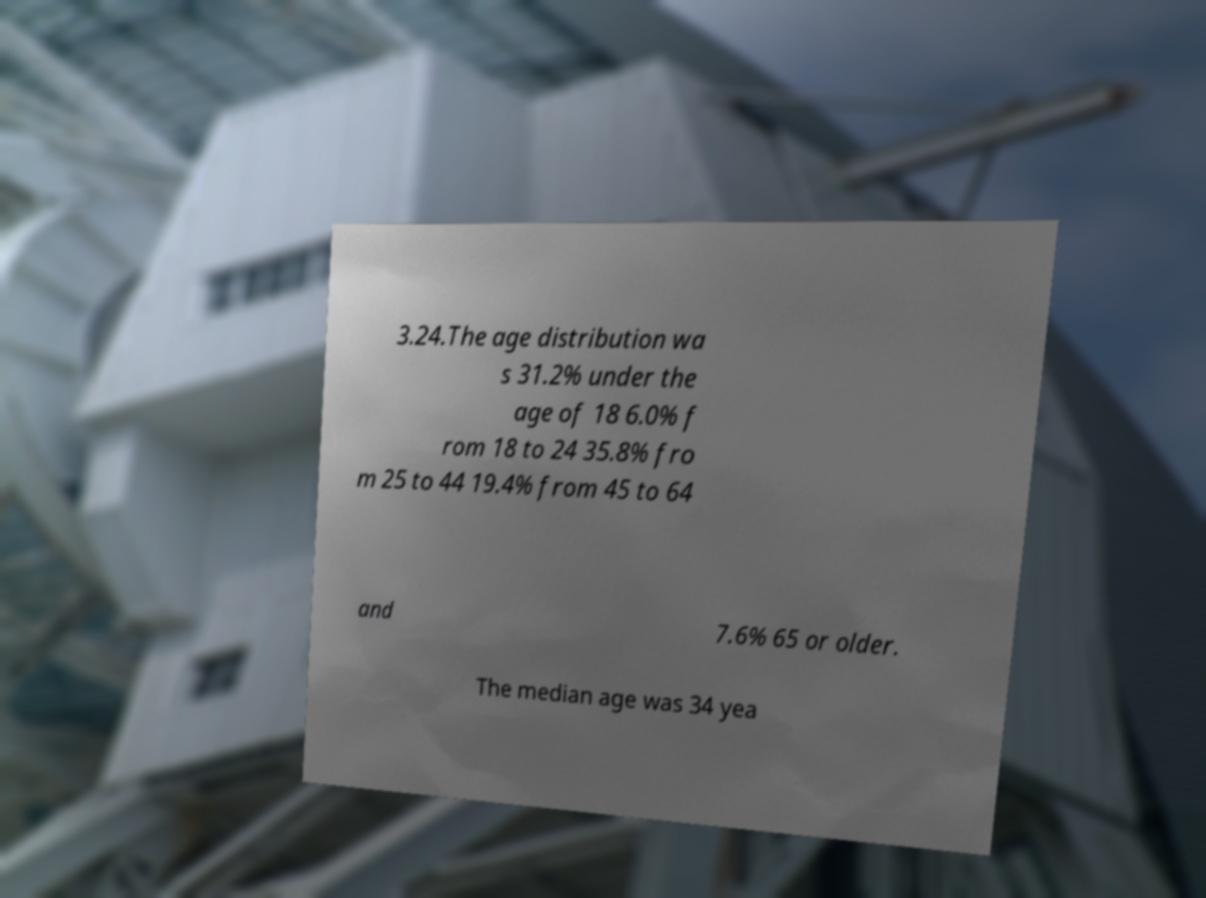Could you extract and type out the text from this image? 3.24.The age distribution wa s 31.2% under the age of 18 6.0% f rom 18 to 24 35.8% fro m 25 to 44 19.4% from 45 to 64 and 7.6% 65 or older. The median age was 34 yea 